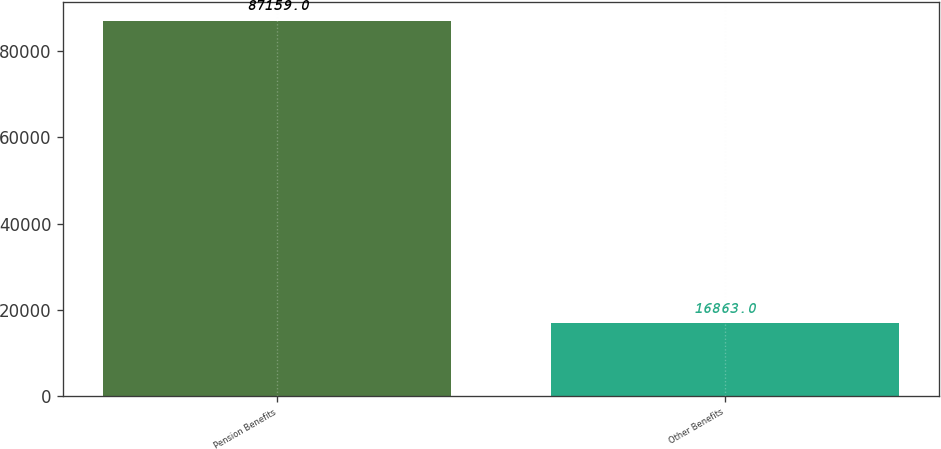<chart> <loc_0><loc_0><loc_500><loc_500><bar_chart><fcel>Pension Benefits<fcel>Other Benefits<nl><fcel>87159<fcel>16863<nl></chart> 